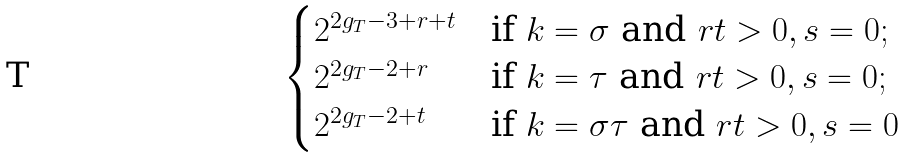<formula> <loc_0><loc_0><loc_500><loc_500>\begin{cases} 2 ^ { 2 g _ { T } - 3 + r + t } & \text {if } k = \sigma \text { and } r t > 0 , s = 0 ; \\ 2 ^ { 2 g _ { T } - 2 + r } & \text {if } k = \tau \text { and } r t > 0 , s = 0 ; \\ 2 ^ { 2 g _ { T } - 2 + t } & \text {if } k = \sigma \tau \text { and } r t > 0 , s = 0 \end{cases}</formula> 